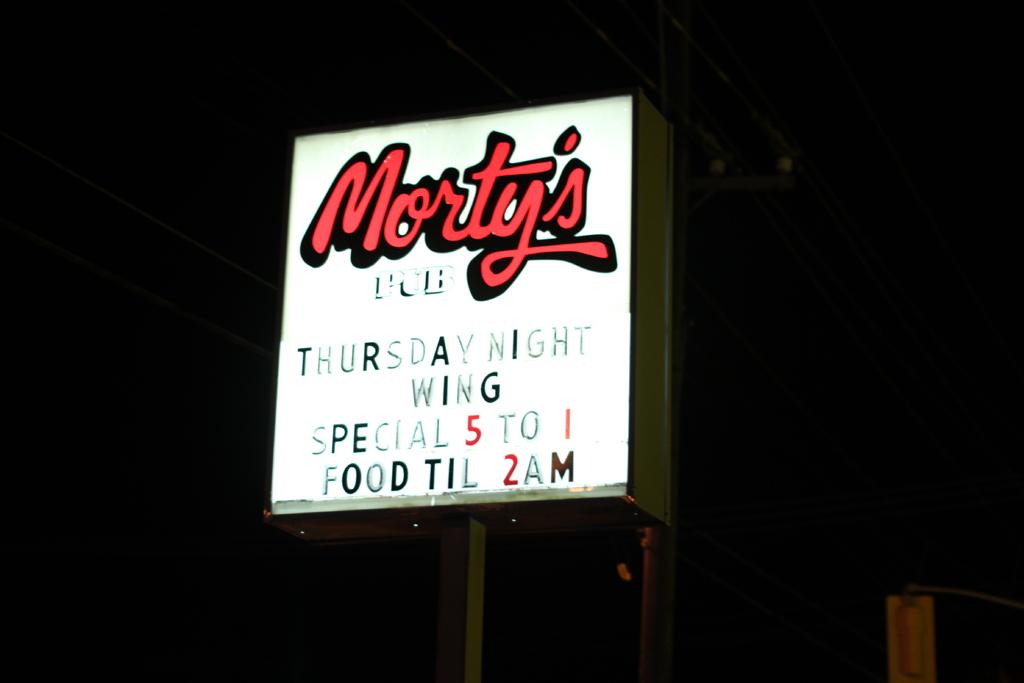What pub is that?
Your response must be concise. Morty's. When is the wing special?
Your response must be concise. Thursday night. 